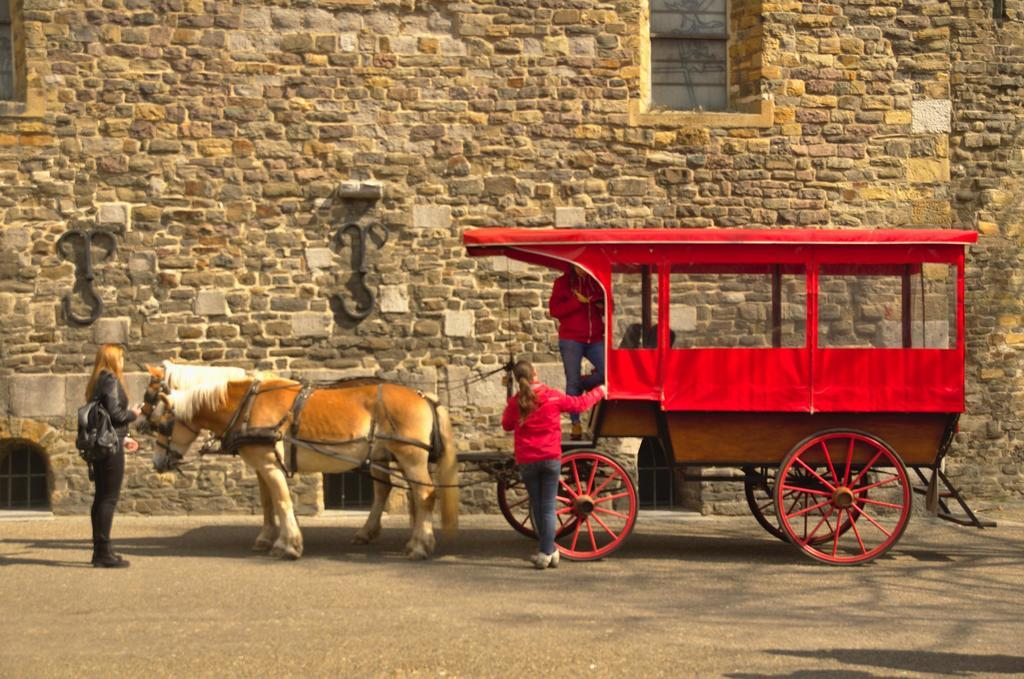How many people are present in the image? There are three people in the image. What can be observed about the clothing of the people in the image? The people are wearing different color dresses. What mode of transportation is visible in the image? There is a horse cart in the image. What can be seen in the background of the image? There is a wall in the background of the image. What type of silver object can be seen being kicked by one of the people in the image? There is no silver object or any kicking action present in the image. 